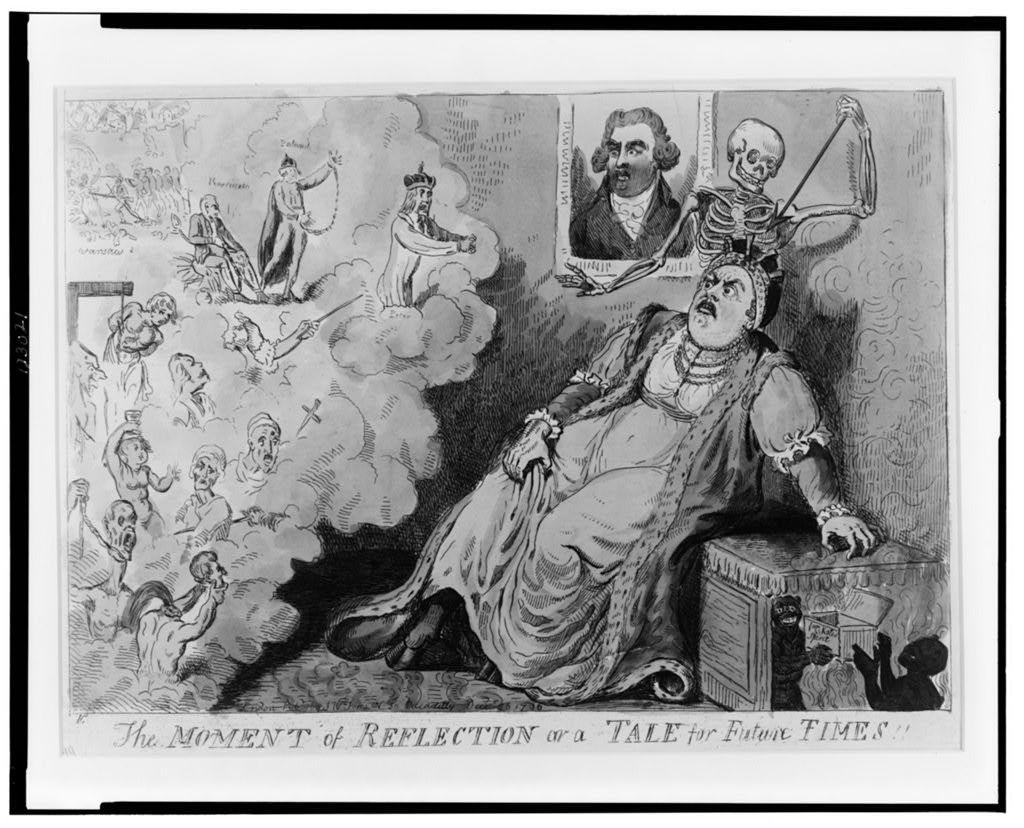What type of visual is the image? The image is a poster. Who or what can be seen in the poster? There are people depicted in the poster. What is the purpose of the frame in the poster? The frame in the poster is likely used to separate or highlight a specific area or image. What other element is present in the poster besides the people? There is a skeleton in the poster. What can be found in the poster that is not an image? There is text in the poster. What color is the yarn used to create the smoke in the poster? There is no yarn or smoke present in the poster; it features people, a frame, a skeleton, and text. 